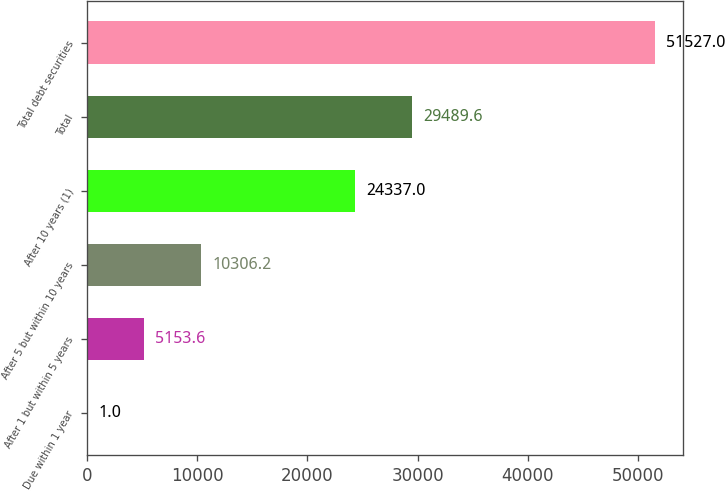Convert chart to OTSL. <chart><loc_0><loc_0><loc_500><loc_500><bar_chart><fcel>Due within 1 year<fcel>After 1 but within 5 years<fcel>After 5 but within 10 years<fcel>After 10 years (1)<fcel>Total<fcel>Total debt securities<nl><fcel>1<fcel>5153.6<fcel>10306.2<fcel>24337<fcel>29489.6<fcel>51527<nl></chart> 